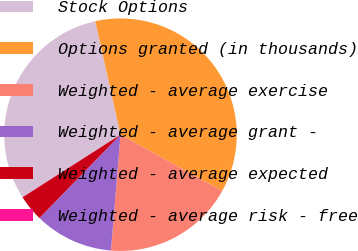Convert chart. <chart><loc_0><loc_0><loc_500><loc_500><pie_chart><fcel>Stock Options<fcel>Options granted (in thousands)<fcel>Weighted - average exercise<fcel>Weighted - average grant -<fcel>Weighted - average expected<fcel>Weighted - average risk - free<nl><fcel>30.55%<fcel>36.53%<fcel>18.27%<fcel>10.97%<fcel>3.67%<fcel>0.02%<nl></chart> 